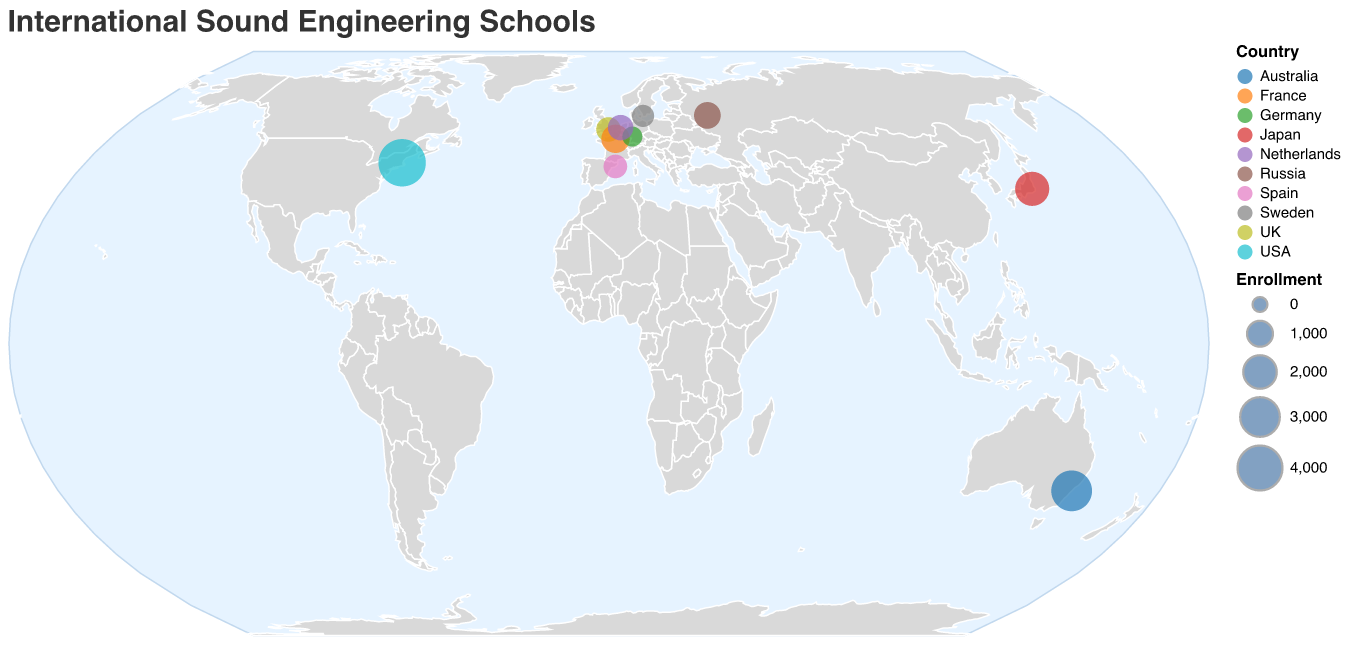How many schools are represented on the map? Count the number of data points or circles on the map. Each circle represents one school.
Answer: 10 Which school has the highest enrollment? Locate the largest circle on the map as size represents enrollment. The largest circle is located at Berklee College of Music.
Answer: Berklee College of Music What is the average enrollment of all the schools? Sum the enrollment numbers of all the schools and divide by the total number of schools. The total enrollment is 4500 + 3200 + 850 + 1300 + 2100 + 400 + 950 + 600 + 1100 + 750 = 15750. The average is 15750 / 10 = 1575.
Answer: 1575 Which country has the most schools listed on the map? Identify and count the number of schools for each country. Each circle’s color indicates its respective country. The USA has the most schools represented.
Answer: USA Compare the enrollment of Berklee College of Music and Conservatoire de Paris. Which is higher and by how much? Look at the size of the circles representing Berklee College of Music and Conservatoire de Paris. Berklee College of Music has 4500 and Conservatoire de Paris has 1300. The difference is 4500 - 1300 = 3200.
Answer: Berklee College of Music by 3200 Which school is located at the easternmost point on the map? Identify the school with the highest longitude value. Tokyo School of Music and Dance is located at 139.6503, which is the highest longitude.
Answer: Tokyo School of Music and Dance What is the total enrollment of schools located in Europe? Sum the enrollment numbers of all the European schools. European schools are Abbey Road Institute, Conservatoire de Paris, Popakademie Baden-Württemberg, The Royal Conservatory of The Hague, Malmö Academy of Music, Moscow State Tchaikovsky Conservatory, and Escola de Música de Barcelona. Their enrollments are 850, 1300, 400, 950, 600, 1100, and 750 totaling 5950.
Answer: 5950 Which country in Europe has the highest total enrollment? Sum the enrollment numbers for each country in Europe and compare. 
- UK: 850
- France: 1300
- Germany: 400
- Netherlands: 950
- Sweden: 600
- Russia: 1100
- Spain: 750
France has the highest total with 1300.
Answer: France Which school has the second lowest enrollment, and what is its enrollment? Identify the second smallest circle, which represents Popakademie Baden-Württemberg at 400. The next smallest circles are Escola de Música de Barcelona with 750.
Answer: Escola de Música de Barcelona, 750 Which continent has the greatest number of schools listed? Identify the continents and count the number of schools in each. Europe, with 7 schools, has the greatest number.
Answer: Europe 